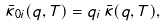<formula> <loc_0><loc_0><loc_500><loc_500>\bar { \kappa } _ { 0 i } ( q , T ) = q _ { i } \, \bar { \kappa } ( q , T ) ,</formula> 